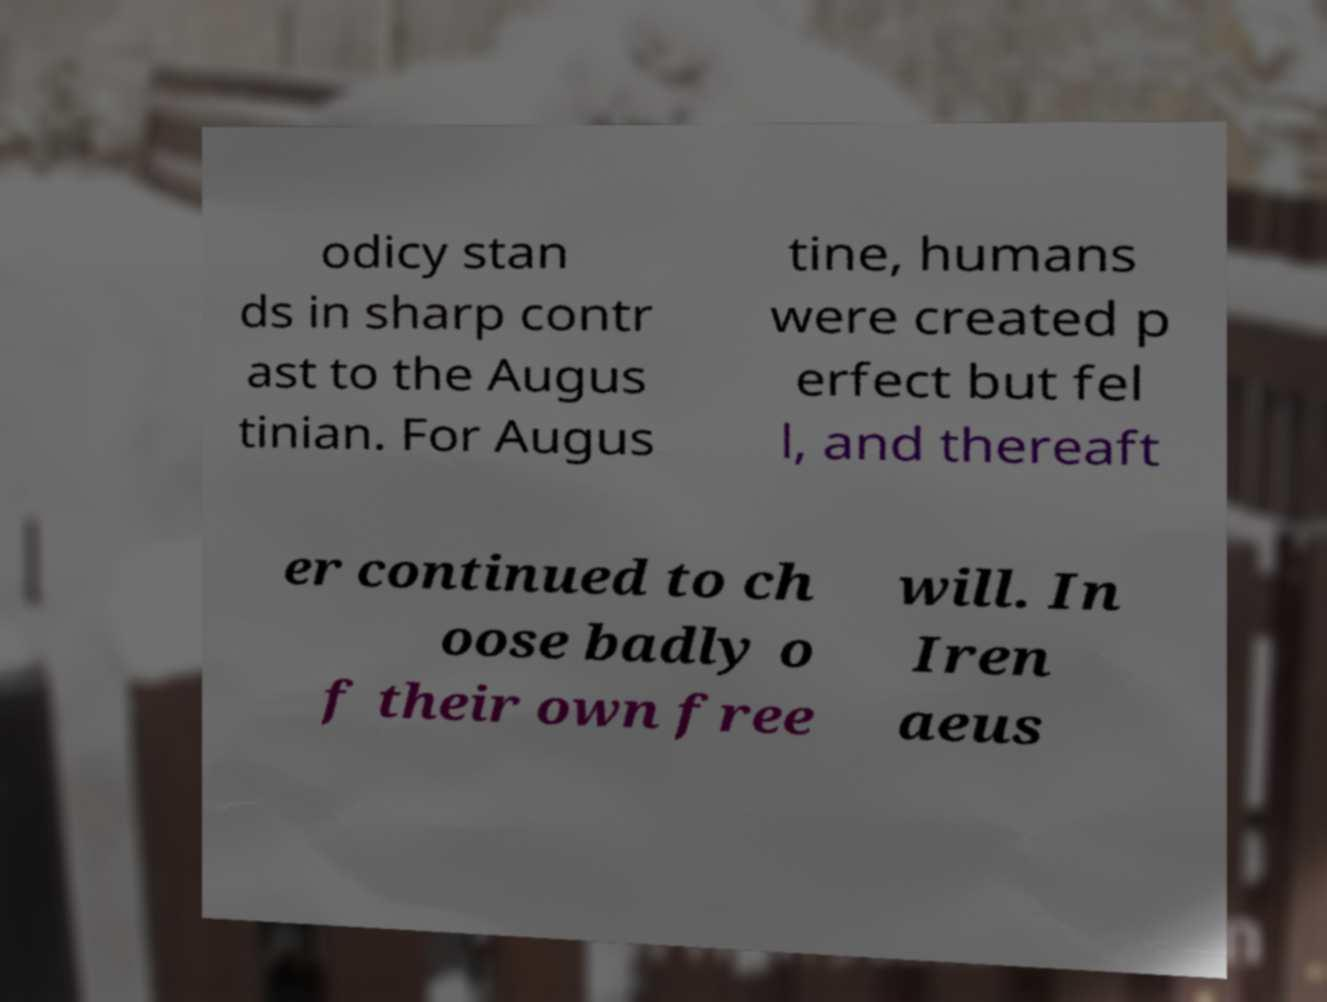Can you accurately transcribe the text from the provided image for me? odicy stan ds in sharp contr ast to the Augus tinian. For Augus tine, humans were created p erfect but fel l, and thereaft er continued to ch oose badly o f their own free will. In Iren aeus 